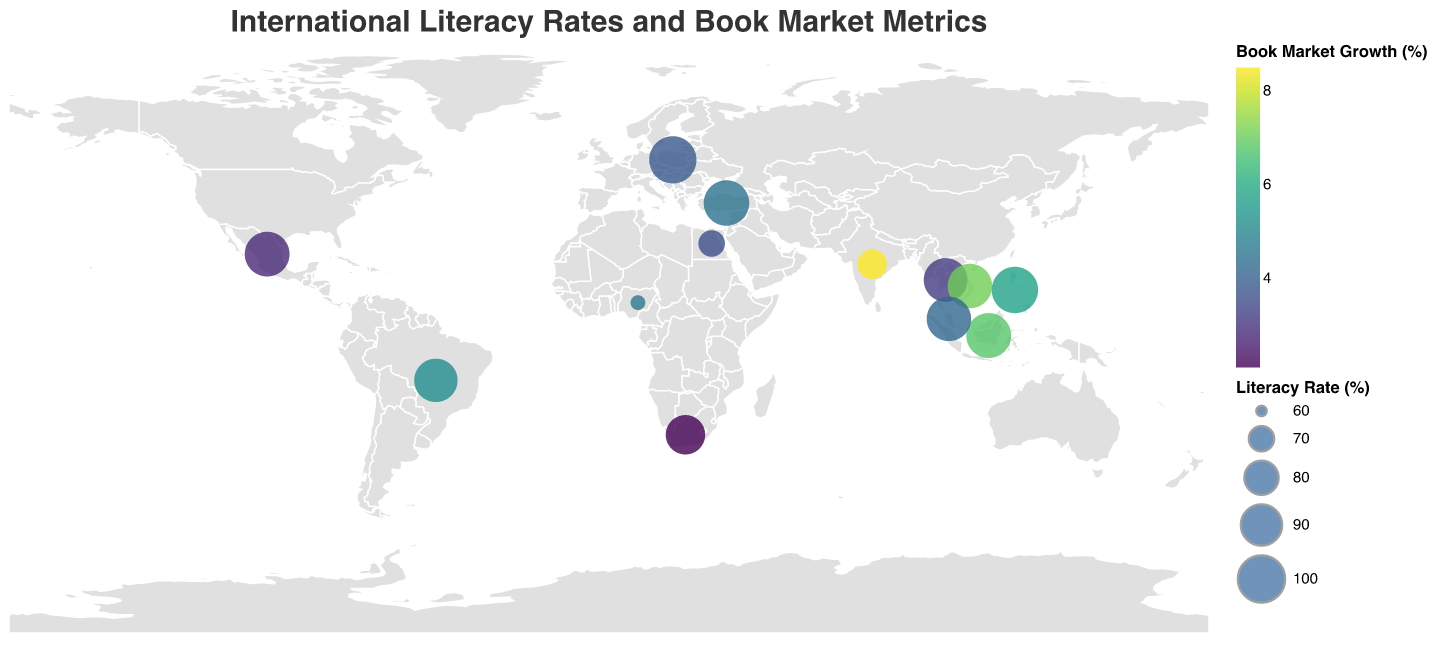What is the title of the figure? The title can be found at the top of the figure. It reads "International Literacy Rates and Book Market Metrics."
Answer: International Literacy Rates and Book Market Metrics Which country has the highest literacy rate? The literacy rate is visualized by the size of the circles. The largest circle represents Poland, which has a literacy rate of 99.8%.
Answer: Poland How many data points are represented on the map? Each country represented by a circle is a data point. There are 13 countries listed in the data.
Answer: 13 Which country shows the highest book market growth? The book market growth is represented by the color scale. India, with the brightest color, shows the highest book market growth at 8.5%.
Answer: India What is the literacy rate of Nigeria? By hovering over or identifying the circle labeled Nigeria, the tooltip indicates a literacy rate of 62.0%.
Answer: 62.0% Which country has the highest number of translated titles? By comparing the translated titles in the tooltips across all countries, Poland has the highest number with 1500 translated titles.
Answer: Poland Compare the e-book adoption rates between South Africa and Mexico. Which one is higher? By checking the e-book adoption values in the tooltips, South Africa has an adoption rate of 20% while Mexico has 18%. South Africa's rate is higher.
Answer: South Africa What is the average literacy rate of all the countries? To calculate the average literacy rate, sum all the literacy rates and divide by the number of countries: (74.4 + 93.2 + 95.7 + 62.0 + 99.8 + 93.8 + 95.0 + 95.4 + 96.7 + 98.2 + 71.2 + 87.0 + 94.9) / 13 = 89.1.
Answer: 89.1 Which country has the lowest e-book adoption rate? The e-book adoption rate is represented in the tooltip. Nigeria, with only 8%, has the lowest rate.
Answer: Nigeria How does the book market growth in Turkey compare to that in Indonesia? Indonesia has a book market growth of 6.8%, while Turkey has a growth rate of 4.5%, making Indonesia's rate higher.
Answer: Indonesia 